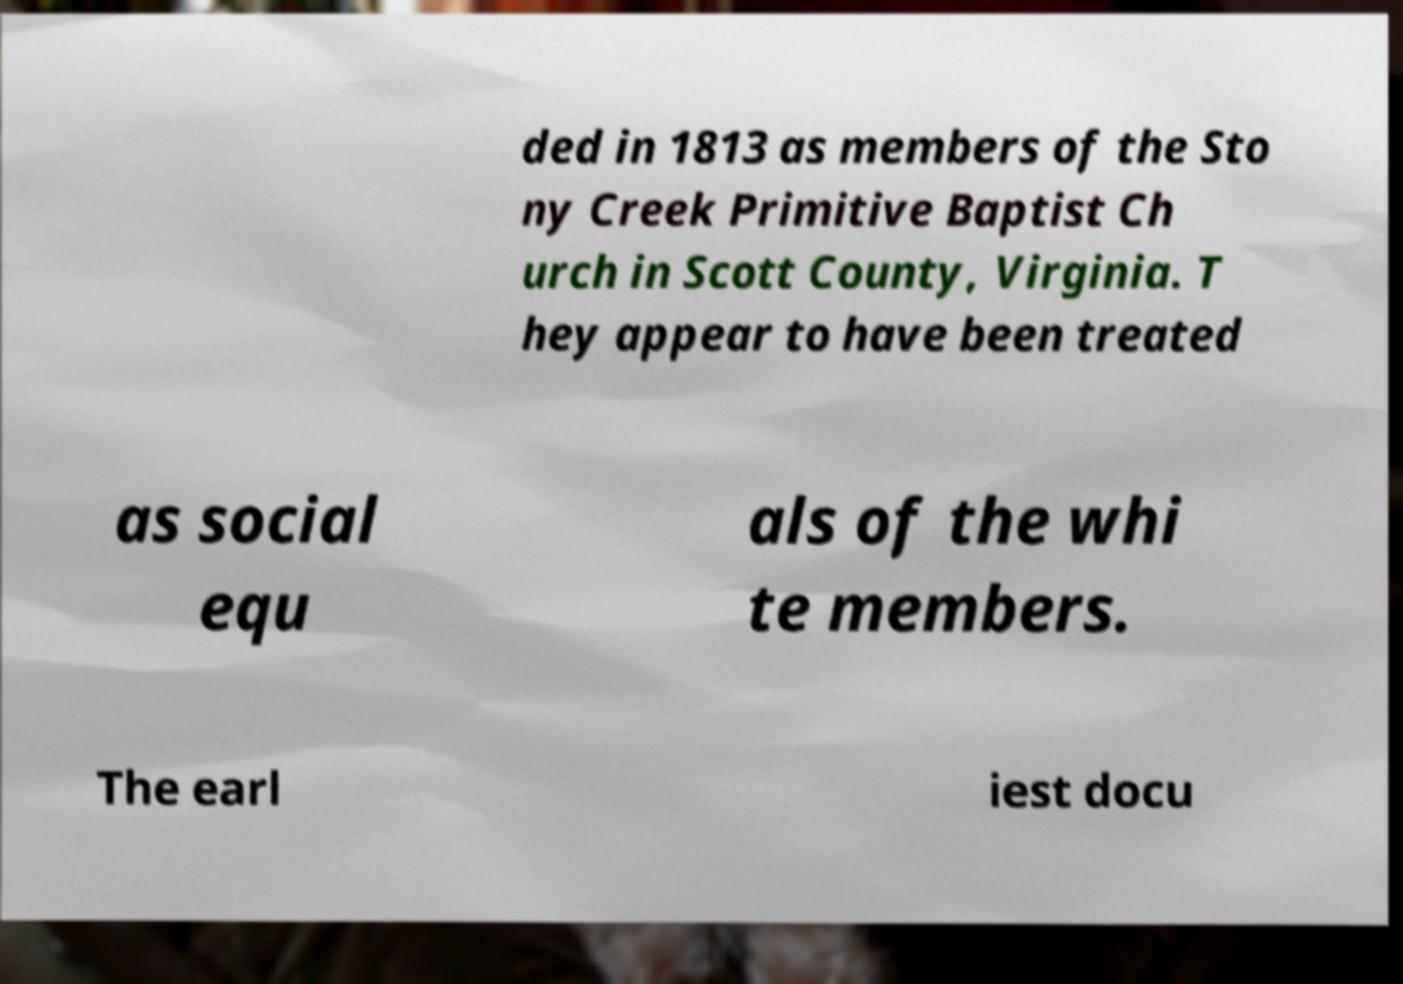Please identify and transcribe the text found in this image. ded in 1813 as members of the Sto ny Creek Primitive Baptist Ch urch in Scott County, Virginia. T hey appear to have been treated as social equ als of the whi te members. The earl iest docu 